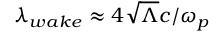Convert formula to latex. <formula><loc_0><loc_0><loc_500><loc_500>\lambda _ { w a k e } \approx 4 \sqrt { \Lambda } c / \omega _ { p }</formula> 